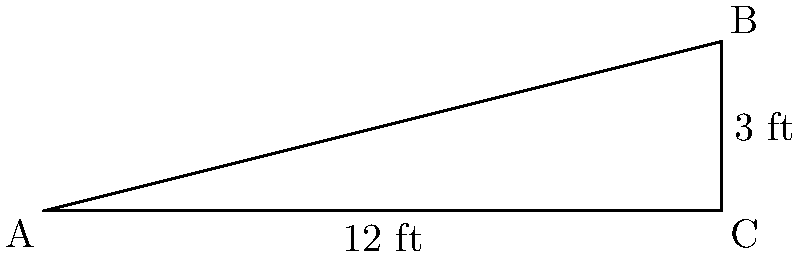An Indigenous community center in Annapolis needs a wheelchair ramp installed at its entrance. The building code requires the ramp to have a slope no steeper than 1:12 (rise:run). If the entrance is 3 feet above ground level and the available horizontal distance for the ramp is 12 feet, what is the angle of elevation of the ramp in degrees? Round your answer to the nearest tenth of a degree. To solve this problem, we'll use the following steps:

1) First, we need to identify the trigonometric ratio that relates the angle of elevation to the given dimensions. In this case, we can use the tangent ratio.

2) The tangent of an angle in a right triangle is the ratio of the opposite side to the adjacent side.

   $\tan(\theta) = \frac{\text{opposite}}{\text{adjacent}} = \frac{\text{rise}}{\text{run}}$

3) From the given information:
   Rise = 3 feet
   Run = 12 feet

4) Substituting these values into the tangent ratio:

   $\tan(\theta) = \frac{3}{12} = \frac{1}{4} = 0.25$

5) To find the angle $\theta$, we need to use the inverse tangent (arctangent) function:

   $\theta = \arctan(0.25)$

6) Using a calculator or trigonometric table:

   $\theta \approx 14.0362435...$

7) Rounding to the nearest tenth of a degree:

   $\theta \approx 14.0°$
Answer: 14.0° 